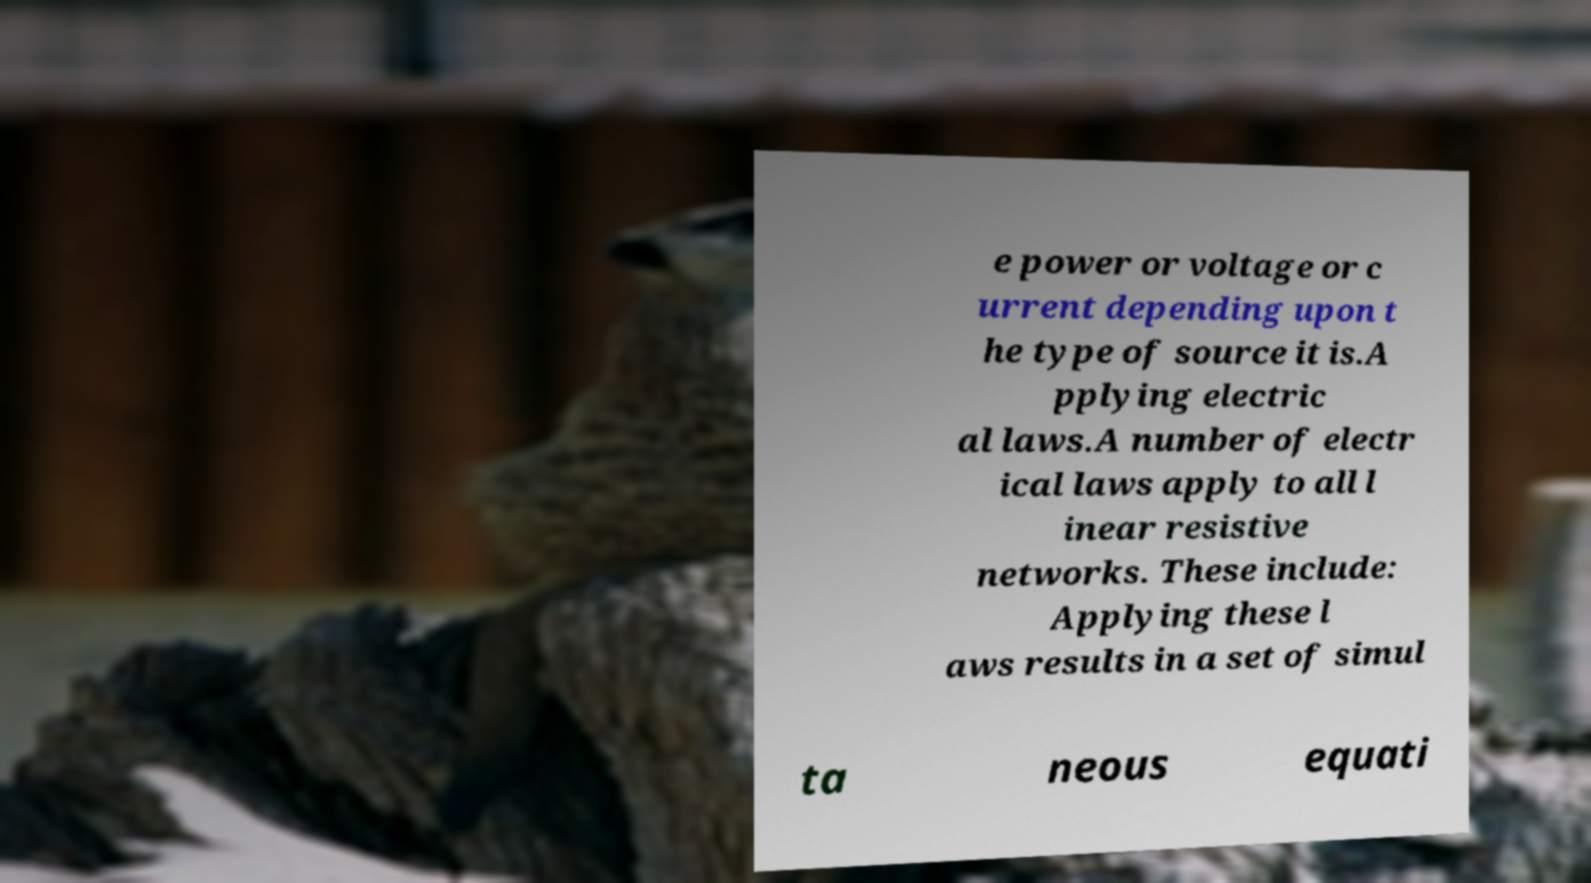Can you accurately transcribe the text from the provided image for me? e power or voltage or c urrent depending upon t he type of source it is.A pplying electric al laws.A number of electr ical laws apply to all l inear resistive networks. These include: Applying these l aws results in a set of simul ta neous equati 